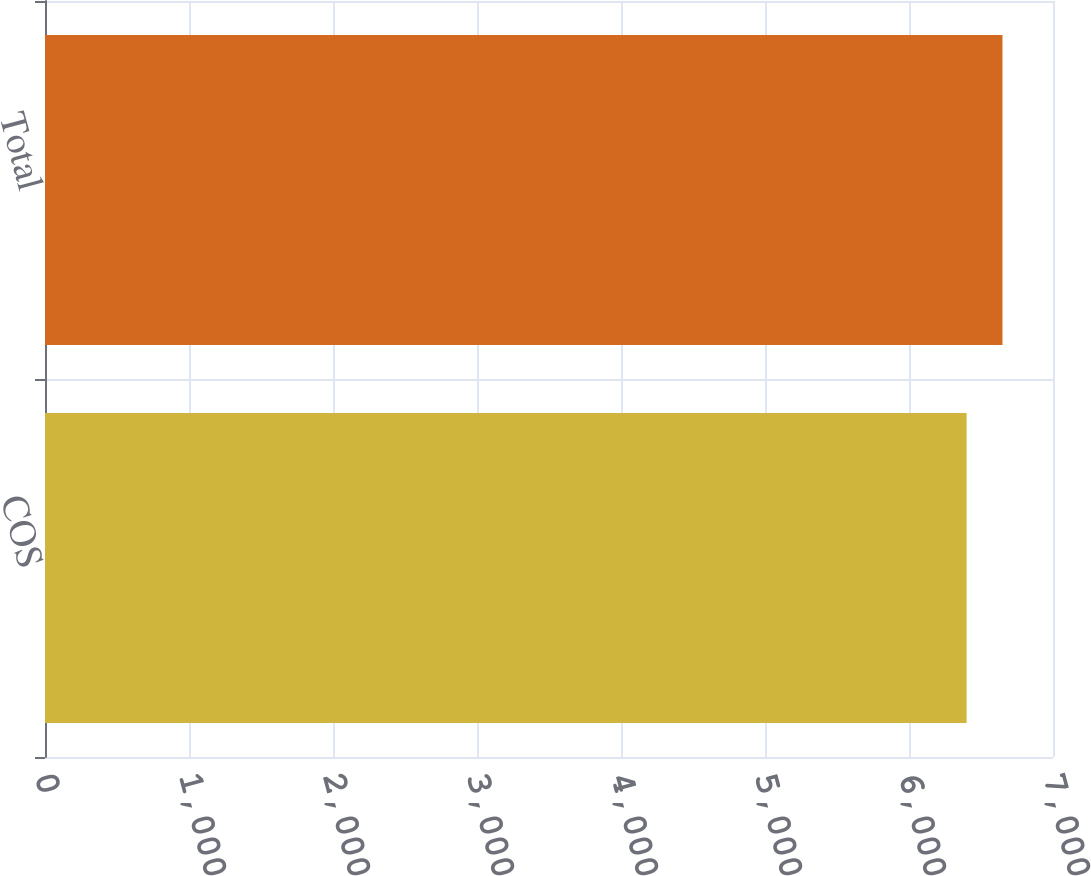Convert chart to OTSL. <chart><loc_0><loc_0><loc_500><loc_500><bar_chart><fcel>COS<fcel>Total<nl><fcel>6400<fcel>6649<nl></chart> 